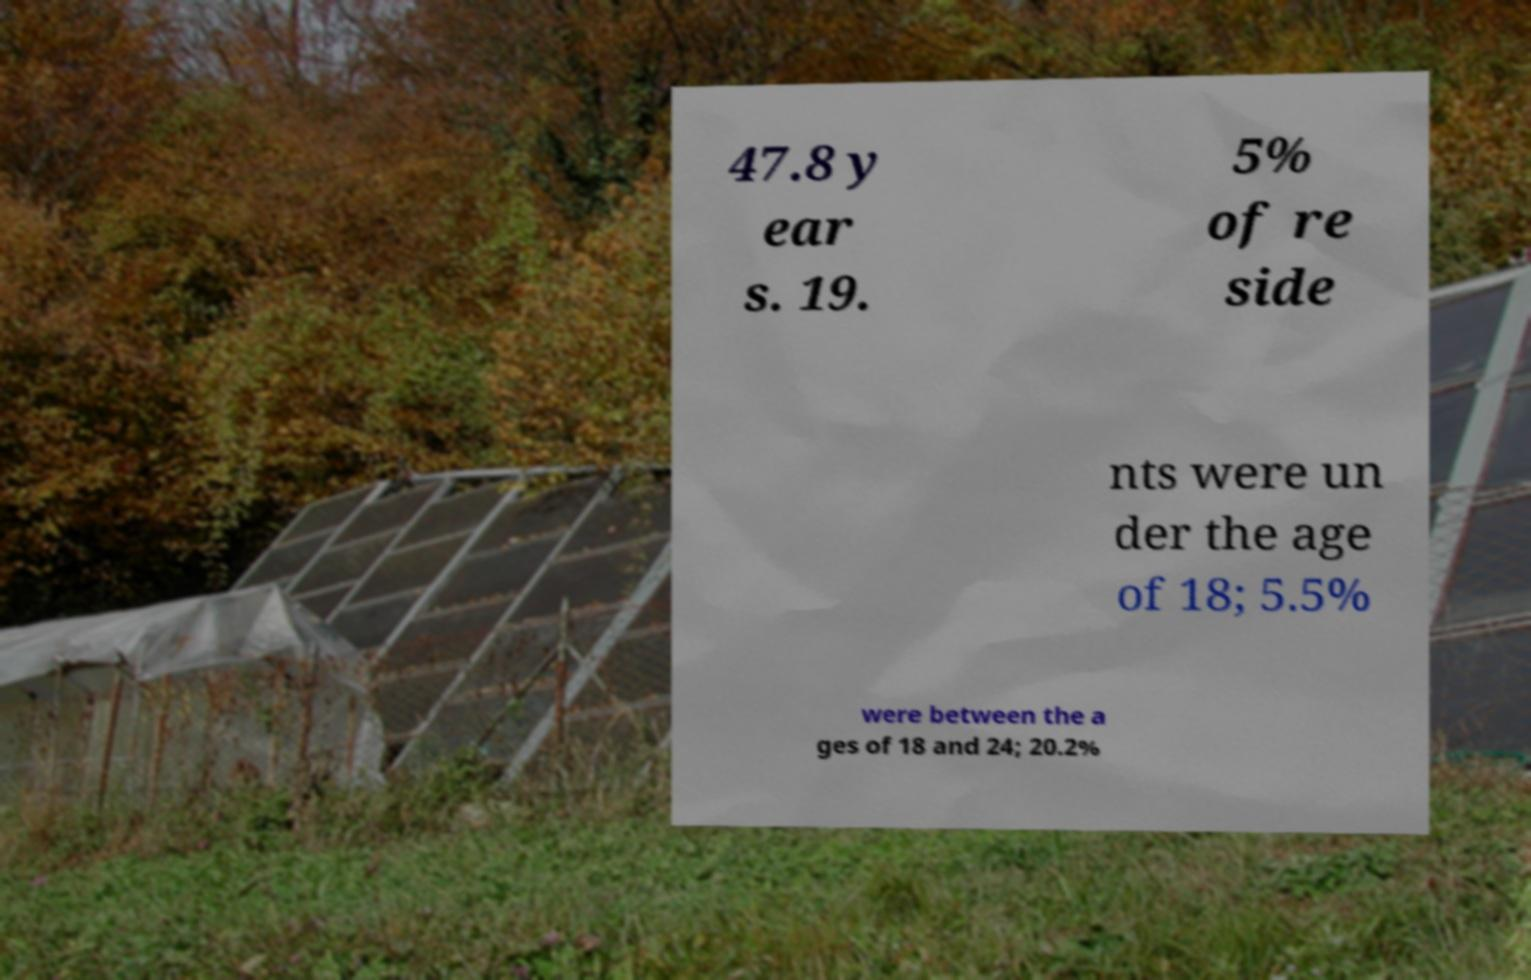I need the written content from this picture converted into text. Can you do that? 47.8 y ear s. 19. 5% of re side nts were un der the age of 18; 5.5% were between the a ges of 18 and 24; 20.2% 